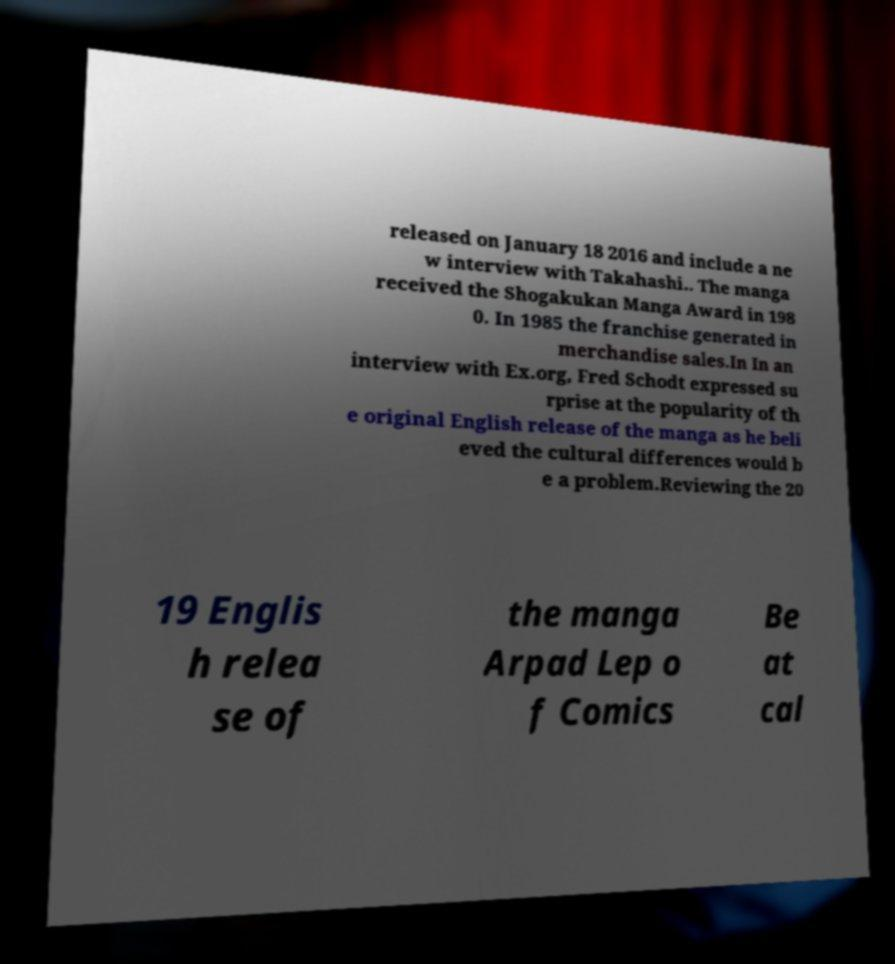There's text embedded in this image that I need extracted. Can you transcribe it verbatim? released on January 18 2016 and include a ne w interview with Takahashi.. The manga received the Shogakukan Manga Award in 198 0. In 1985 the franchise generated in merchandise sales.In In an interview with Ex.org, Fred Schodt expressed su rprise at the popularity of th e original English release of the manga as he beli eved the cultural differences would b e a problem.Reviewing the 20 19 Englis h relea se of the manga Arpad Lep o f Comics Be at cal 